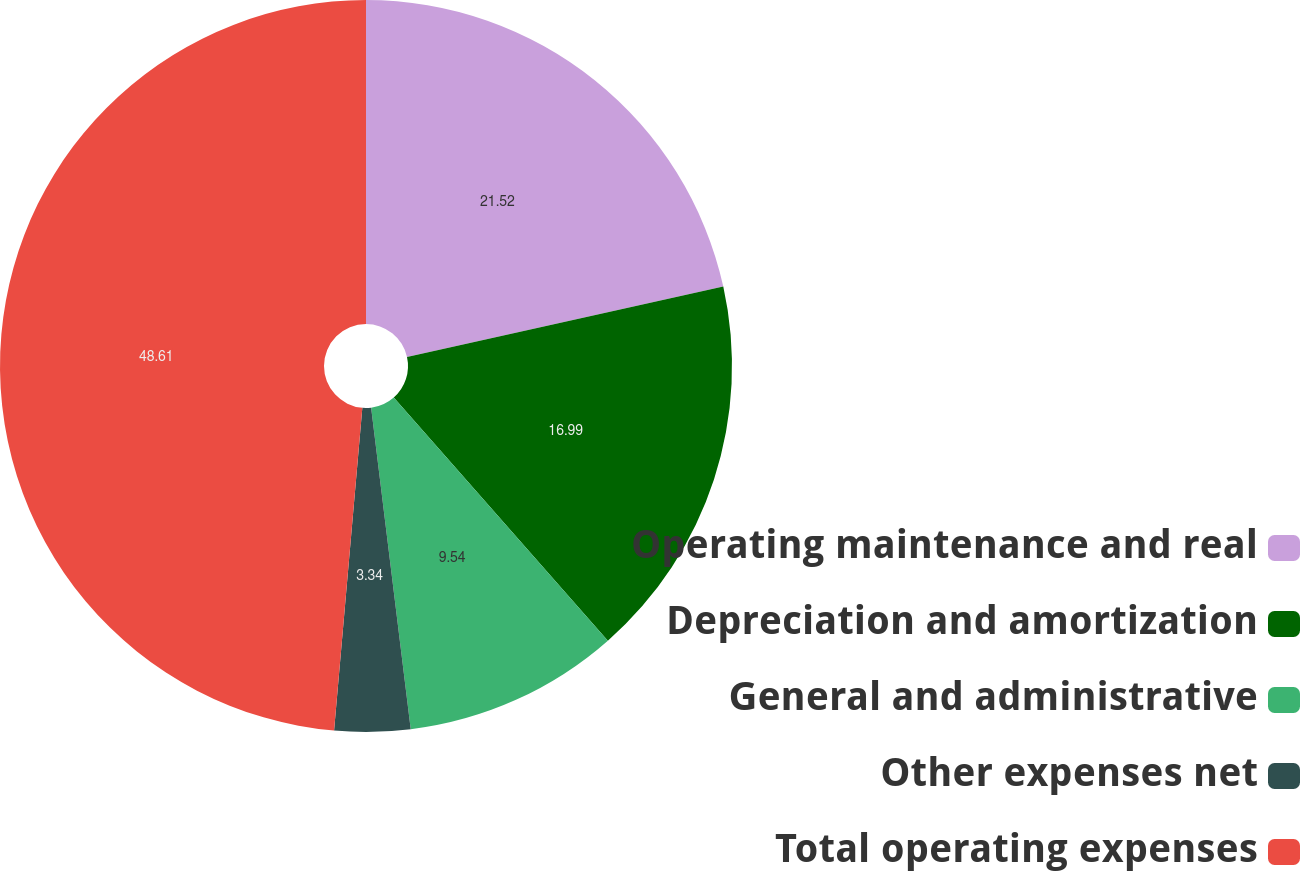Convert chart to OTSL. <chart><loc_0><loc_0><loc_500><loc_500><pie_chart><fcel>Operating maintenance and real<fcel>Depreciation and amortization<fcel>General and administrative<fcel>Other expenses net<fcel>Total operating expenses<nl><fcel>21.52%<fcel>16.99%<fcel>9.54%<fcel>3.34%<fcel>48.61%<nl></chart> 